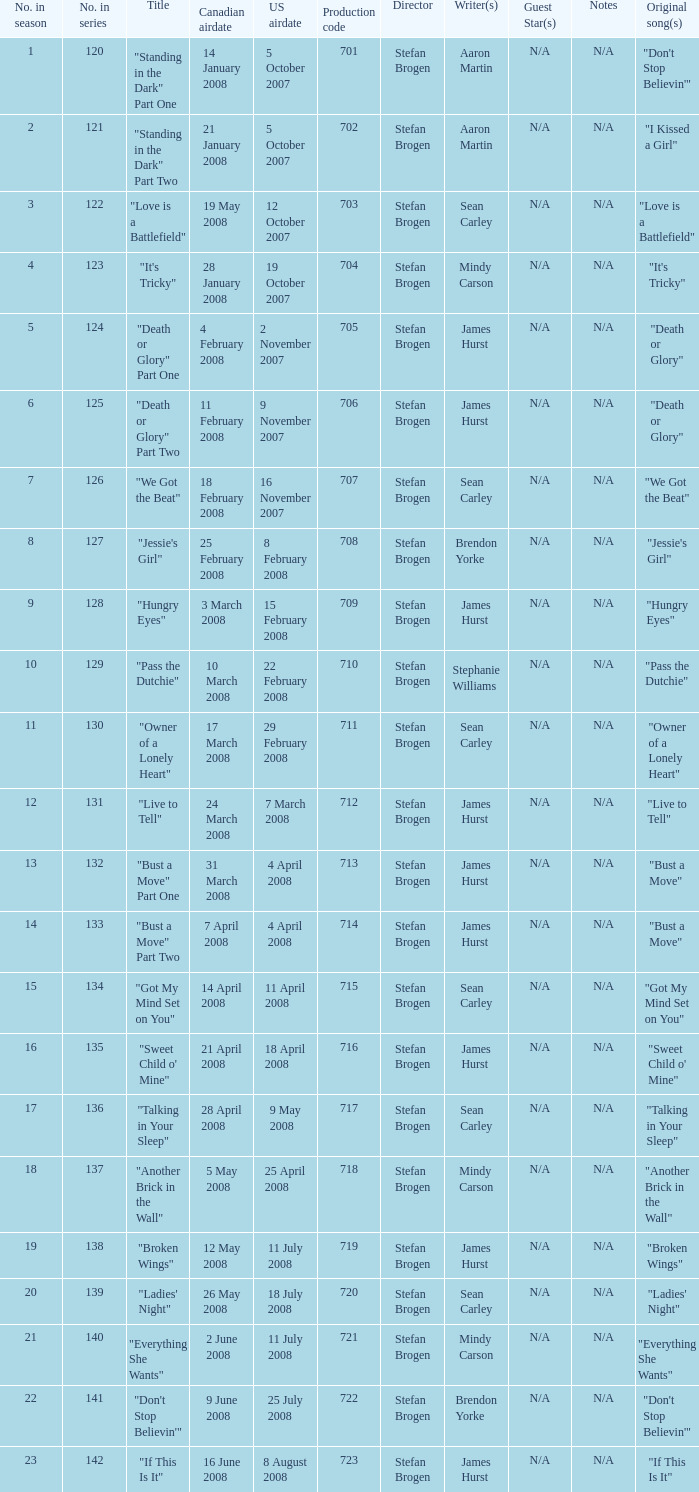For the episode(s) aired in the U.S. on 4 april 2008, what were the names? "Bust a Move" Part One, "Bust a Move" Part Two. 